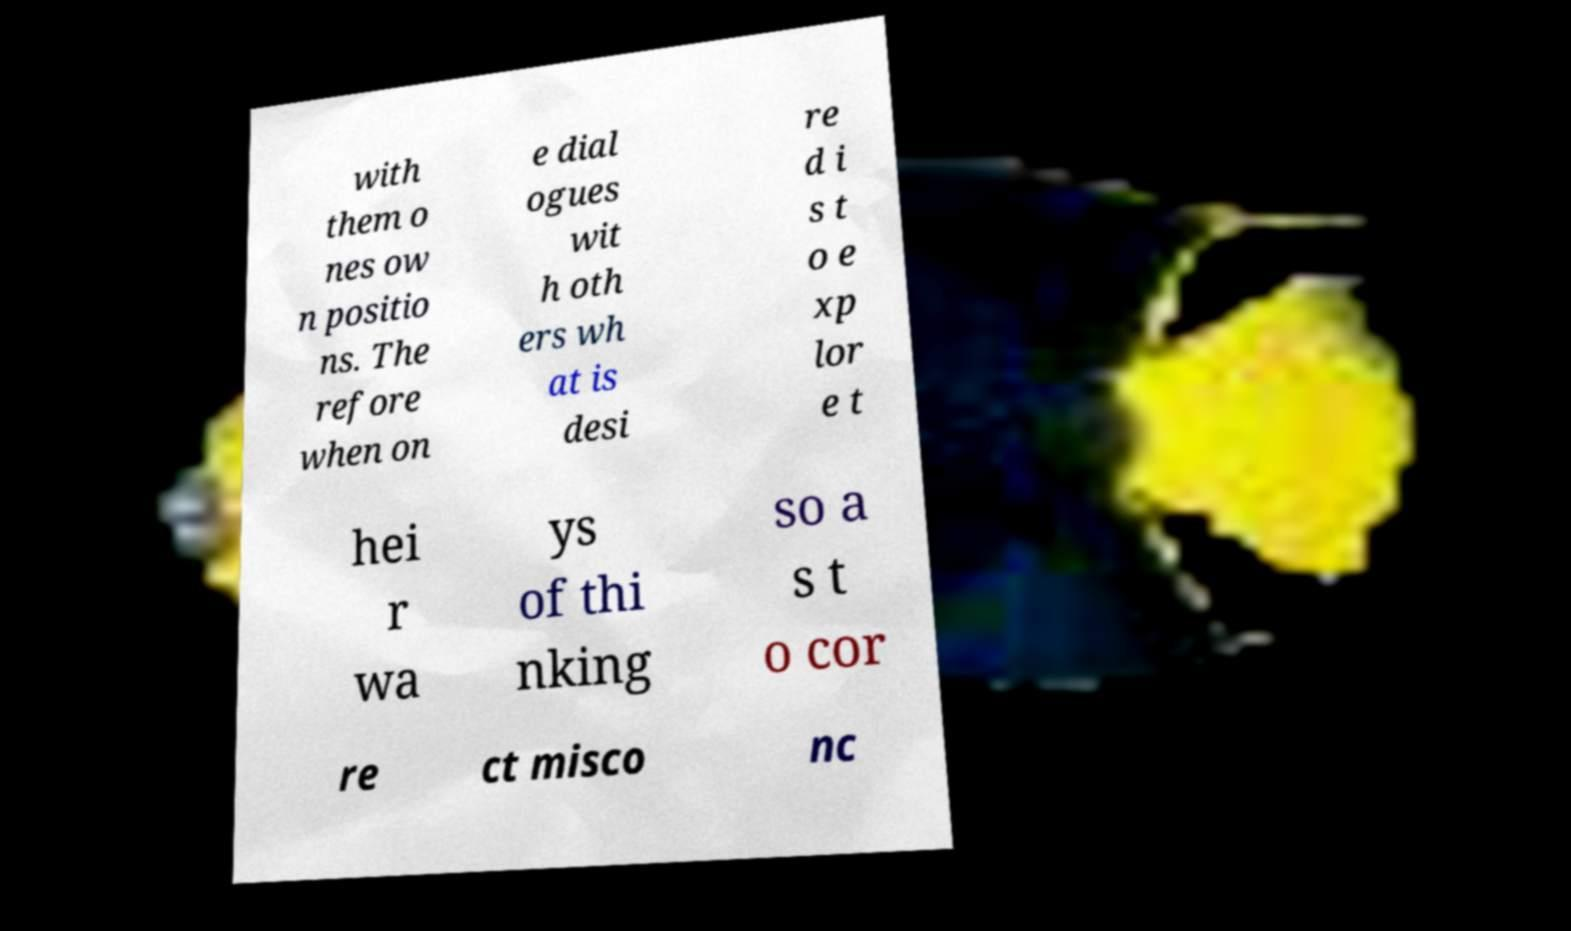What messages or text are displayed in this image? I need them in a readable, typed format. with them o nes ow n positio ns. The refore when on e dial ogues wit h oth ers wh at is desi re d i s t o e xp lor e t hei r wa ys of thi nking so a s t o cor re ct misco nc 